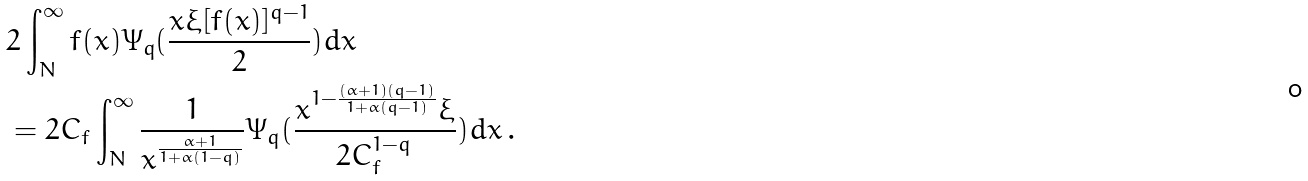<formula> <loc_0><loc_0><loc_500><loc_500>& 2 \int _ { N } ^ { \infty } f ( x ) \Psi _ { q } ( \frac { x \xi [ f ( x ) ] ^ { q - 1 } } { 2 } ) d x \\ & = 2 C _ { f } \int _ { N } ^ { \infty } \frac { 1 } { x ^ { \frac { \alpha + 1 } { 1 + \alpha ( 1 - q ) } } } \Psi _ { q } ( \frac { x ^ { 1 - \frac { ( \alpha + 1 ) ( q - 1 ) } { 1 + \alpha ( q - 1 ) } } \xi } { 2 C _ { f } ^ { 1 - q } } ) d x \, .</formula> 